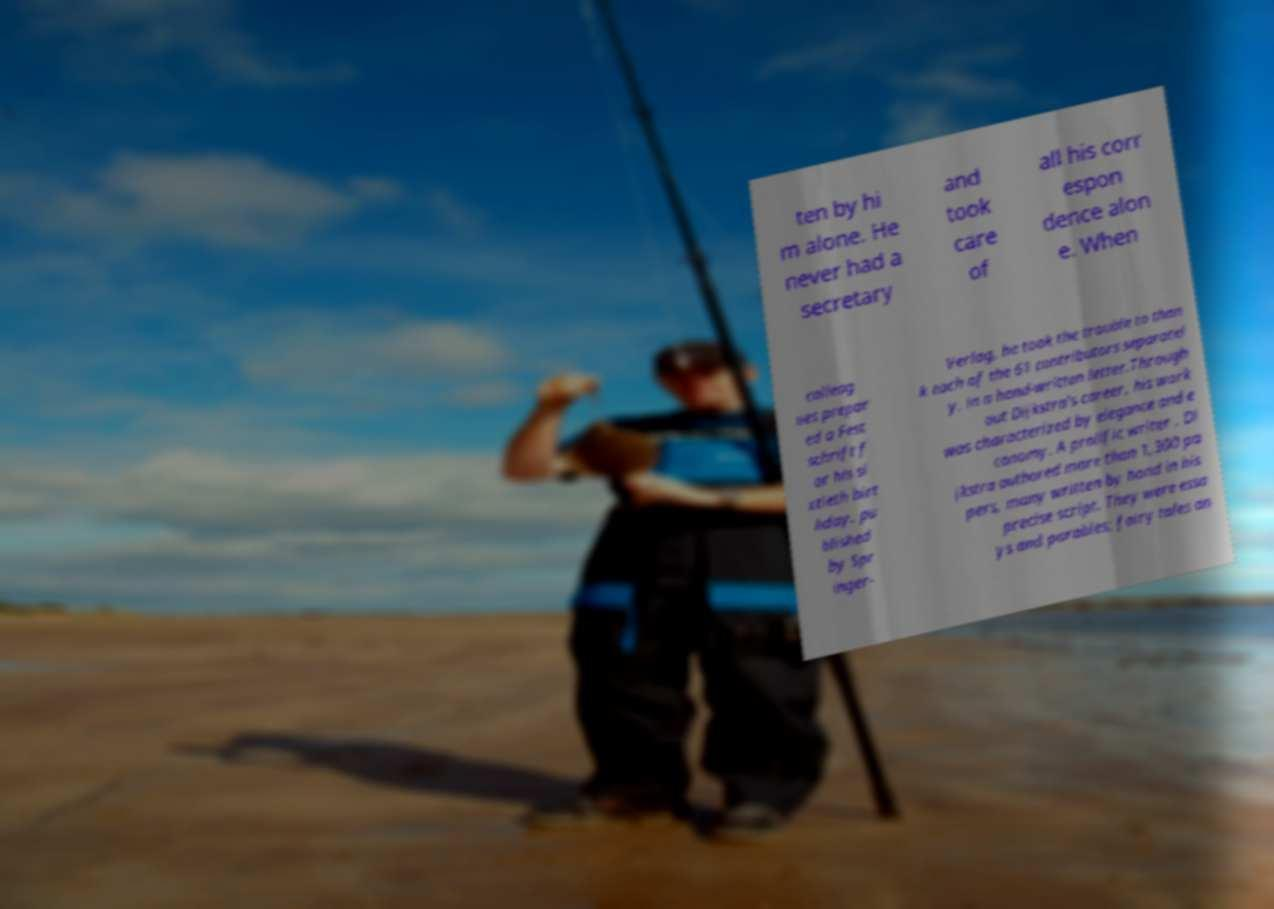There's text embedded in this image that I need extracted. Can you transcribe it verbatim? ten by hi m alone. He never had a secretary and took care of all his corr espon dence alon e. When colleag ues prepar ed a Fest schrift f or his si xtieth birt hday, pu blished by Spr inger- Verlag, he took the trouble to than k each of the 61 contributors separatel y, in a hand-written letter.Through out Dijkstra's career, his work was characterized by elegance and e conomy. A prolific writer , Di jkstra authored more than 1,300 pa pers, many written by hand in his precise script. They were essa ys and parables; fairy tales an 